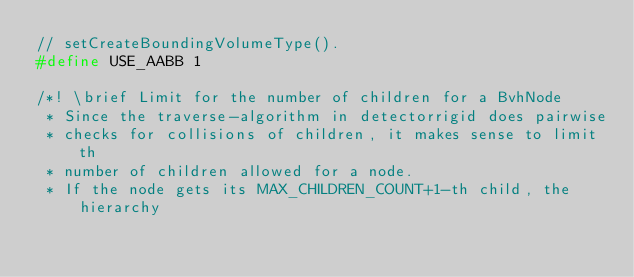Convert code to text. <code><loc_0><loc_0><loc_500><loc_500><_C_>// setCreateBoundingVolumeType().
#define USE_AABB 1

/*! \brief Limit for the number of children for a BvhNode
 * Since the traverse-algorithm in detectorrigid does pairwise
 * checks for collisions of children, it makes sense to limit th
 * number of children allowed for a node.
 * If the node gets its MAX_CHILDREN_COUNT+1-th child, the hierarchy</code> 